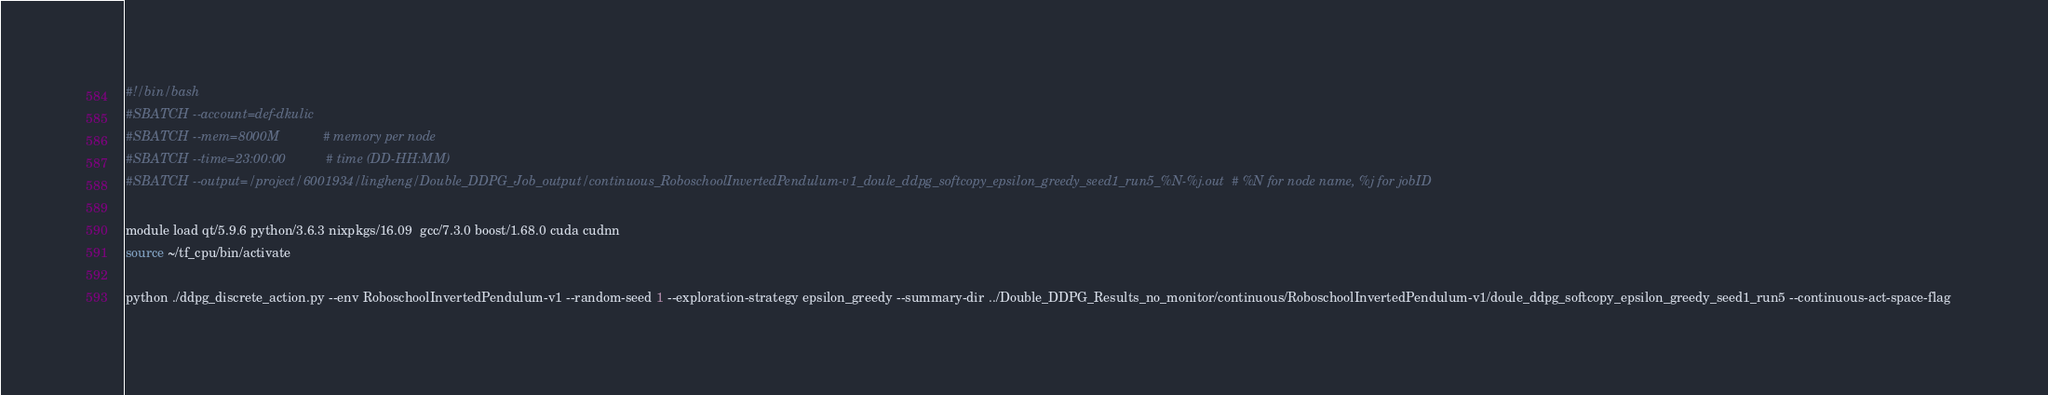Convert code to text. <code><loc_0><loc_0><loc_500><loc_500><_Bash_>#!/bin/bash
#SBATCH --account=def-dkulic
#SBATCH --mem=8000M            # memory per node
#SBATCH --time=23:00:00           # time (DD-HH:MM)
#SBATCH --output=/project/6001934/lingheng/Double_DDPG_Job_output/continuous_RoboschoolInvertedPendulum-v1_doule_ddpg_softcopy_epsilon_greedy_seed1_run5_%N-%j.out  # %N for node name, %j for jobID

module load qt/5.9.6 python/3.6.3 nixpkgs/16.09  gcc/7.3.0 boost/1.68.0 cuda cudnn
source ~/tf_cpu/bin/activate

python ./ddpg_discrete_action.py --env RoboschoolInvertedPendulum-v1 --random-seed 1 --exploration-strategy epsilon_greedy --summary-dir ../Double_DDPG_Results_no_monitor/continuous/RoboschoolInvertedPendulum-v1/doule_ddpg_softcopy_epsilon_greedy_seed1_run5 --continuous-act-space-flag   

</code> 